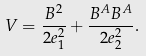<formula> <loc_0><loc_0><loc_500><loc_500>V = \frac { B ^ { 2 } } { 2 e _ { 1 } ^ { 2 } } + \frac { B ^ { A } B ^ { A } } { 2 e _ { 2 } ^ { 2 } } .</formula> 